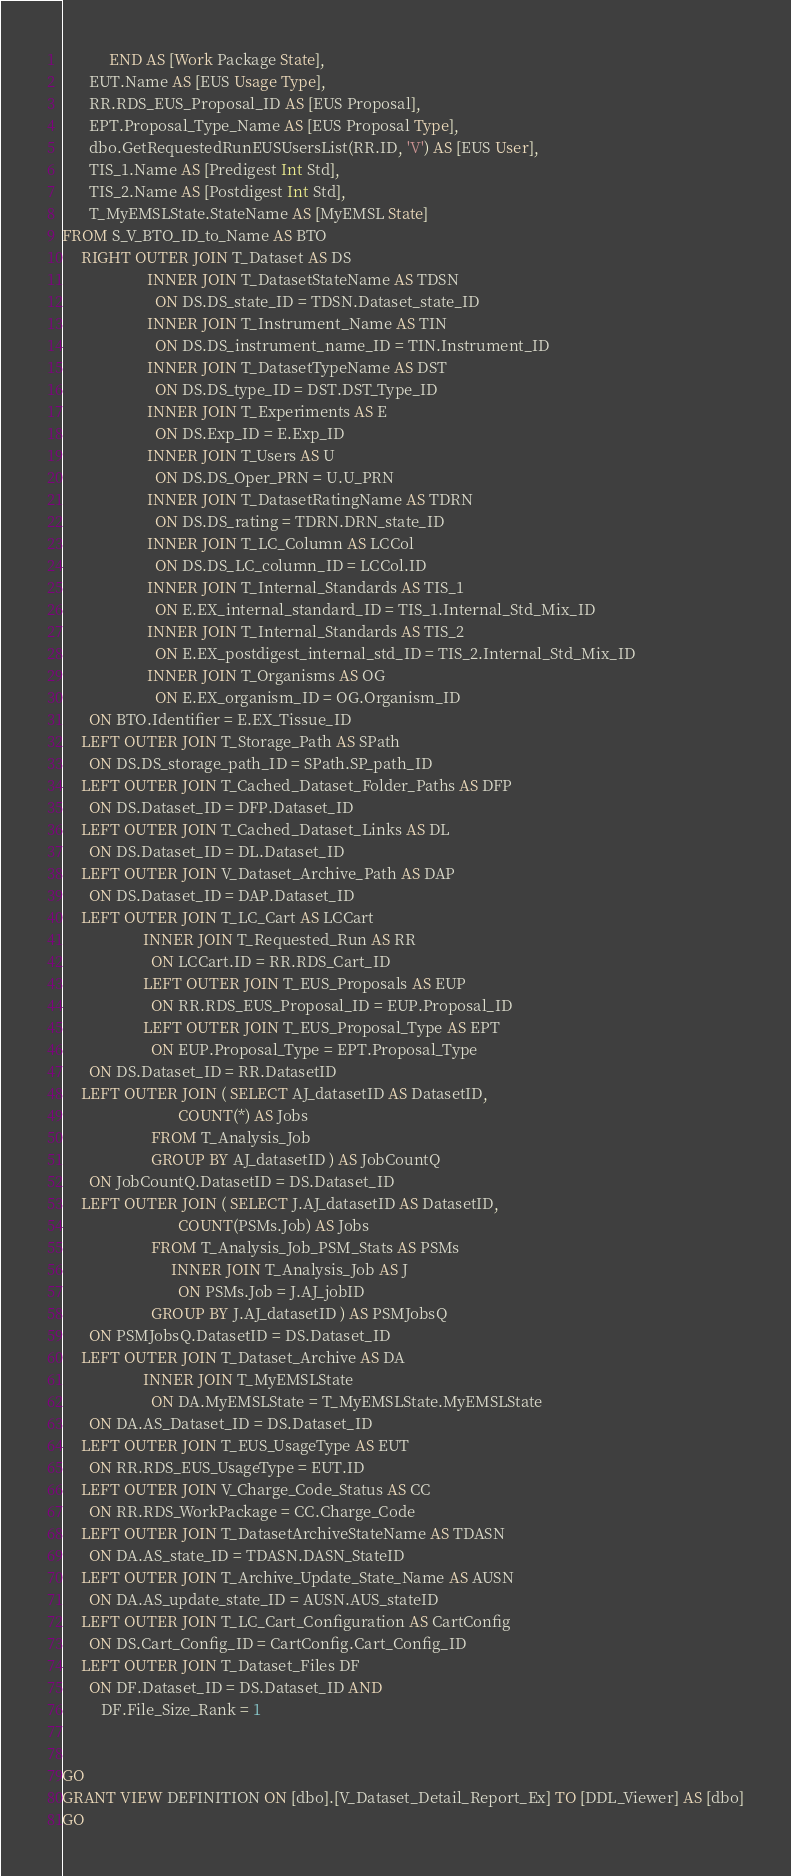Convert code to text. <code><loc_0><loc_0><loc_500><loc_500><_SQL_>            END AS [Work Package State],
       EUT.Name AS [EUS Usage Type],
       RR.RDS_EUS_Proposal_ID AS [EUS Proposal],
       EPT.Proposal_Type_Name AS [EUS Proposal Type],
       dbo.GetRequestedRunEUSUsersList(RR.ID, 'V') AS [EUS User],
       TIS_1.Name AS [Predigest Int Std],
       TIS_2.Name AS [Postdigest Int Std],
       T_MyEMSLState.StateName AS [MyEMSL State]
FROM S_V_BTO_ID_to_Name AS BTO
     RIGHT OUTER JOIN T_Dataset AS DS
                      INNER JOIN T_DatasetStateName AS TDSN
                        ON DS.DS_state_ID = TDSN.Dataset_state_ID
                      INNER JOIN T_Instrument_Name AS TIN
                        ON DS.DS_instrument_name_ID = TIN.Instrument_ID
                      INNER JOIN T_DatasetTypeName AS DST
                        ON DS.DS_type_ID = DST.DST_Type_ID
                      INNER JOIN T_Experiments AS E
                        ON DS.Exp_ID = E.Exp_ID
                      INNER JOIN T_Users AS U
                        ON DS.DS_Oper_PRN = U.U_PRN
                      INNER JOIN T_DatasetRatingName AS TDRN
                        ON DS.DS_rating = TDRN.DRN_state_ID
                      INNER JOIN T_LC_Column AS LCCol
                        ON DS.DS_LC_column_ID = LCCol.ID
                      INNER JOIN T_Internal_Standards AS TIS_1
                        ON E.EX_internal_standard_ID = TIS_1.Internal_Std_Mix_ID
                      INNER JOIN T_Internal_Standards AS TIS_2
                        ON E.EX_postdigest_internal_std_ID = TIS_2.Internal_Std_Mix_ID
                      INNER JOIN T_Organisms AS OG
                        ON E.EX_organism_ID = OG.Organism_ID
       ON BTO.Identifier = E.EX_Tissue_ID
     LEFT OUTER JOIN T_Storage_Path AS SPath
       ON DS.DS_storage_path_ID = SPath.SP_path_ID
     LEFT OUTER JOIN T_Cached_Dataset_Folder_Paths AS DFP
       ON DS.Dataset_ID = DFP.Dataset_ID
     LEFT OUTER JOIN T_Cached_Dataset_Links AS DL
       ON DS.Dataset_ID = DL.Dataset_ID
     LEFT OUTER JOIN V_Dataset_Archive_Path AS DAP
       ON DS.Dataset_ID = DAP.Dataset_ID
     LEFT OUTER JOIN T_LC_Cart AS LCCart
                     INNER JOIN T_Requested_Run AS RR
                       ON LCCart.ID = RR.RDS_Cart_ID
                     LEFT OUTER JOIN T_EUS_Proposals AS EUP
                       ON RR.RDS_EUS_Proposal_ID = EUP.Proposal_ID
                     LEFT OUTER JOIN T_EUS_Proposal_Type AS EPT
                       ON EUP.Proposal_Type = EPT.Proposal_Type
       ON DS.Dataset_ID = RR.DatasetID
     LEFT OUTER JOIN ( SELECT AJ_datasetID AS DatasetID,
                              COUNT(*) AS Jobs
                       FROM T_Analysis_Job
                       GROUP BY AJ_datasetID ) AS JobCountQ
       ON JobCountQ.DatasetID = DS.Dataset_ID
     LEFT OUTER JOIN ( SELECT J.AJ_datasetID AS DatasetID,
                              COUNT(PSMs.Job) AS Jobs
                       FROM T_Analysis_Job_PSM_Stats AS PSMs
                            INNER JOIN T_Analysis_Job AS J
                              ON PSMs.Job = J.AJ_jobID
                       GROUP BY J.AJ_datasetID ) AS PSMJobsQ
       ON PSMJobsQ.DatasetID = DS.Dataset_ID    
     LEFT OUTER JOIN T_Dataset_Archive AS DA
                     INNER JOIN T_MyEMSLState
                       ON DA.MyEMSLState = T_MyEMSLState.MyEMSLState
       ON DA.AS_Dataset_ID = DS.Dataset_ID
     LEFT OUTER JOIN T_EUS_UsageType AS EUT
       ON RR.RDS_EUS_UsageType = EUT.ID
     LEFT OUTER JOIN V_Charge_Code_Status AS CC
       ON RR.RDS_WorkPackage = CC.Charge_Code
     LEFT OUTER JOIN T_DatasetArchiveStateName AS TDASN
       ON DA.AS_state_ID = TDASN.DASN_StateID
     LEFT OUTER JOIN T_Archive_Update_State_Name AS AUSN
       ON DA.AS_update_state_ID = AUSN.AUS_stateID
     LEFT OUTER JOIN T_LC_Cart_Configuration AS CartConfig
       ON DS.Cart_Config_ID = CartConfig.Cart_Config_ID
     LEFT OUTER JOIN T_Dataset_Files DF
       ON DF.Dataset_ID = DS.Dataset_ID AND
          DF.File_Size_Rank = 1


GO
GRANT VIEW DEFINITION ON [dbo].[V_Dataset_Detail_Report_Ex] TO [DDL_Viewer] AS [dbo]
GO
</code> 